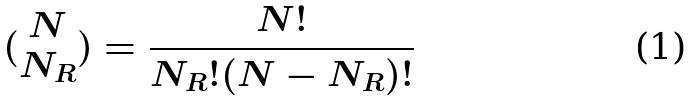Convert formula to latex. <formula><loc_0><loc_0><loc_500><loc_500>( \begin{matrix} N \\ N _ { R } \end{matrix} ) = \frac { N ! } { N _ { R } ! ( N - N _ { R } ) ! }</formula> 